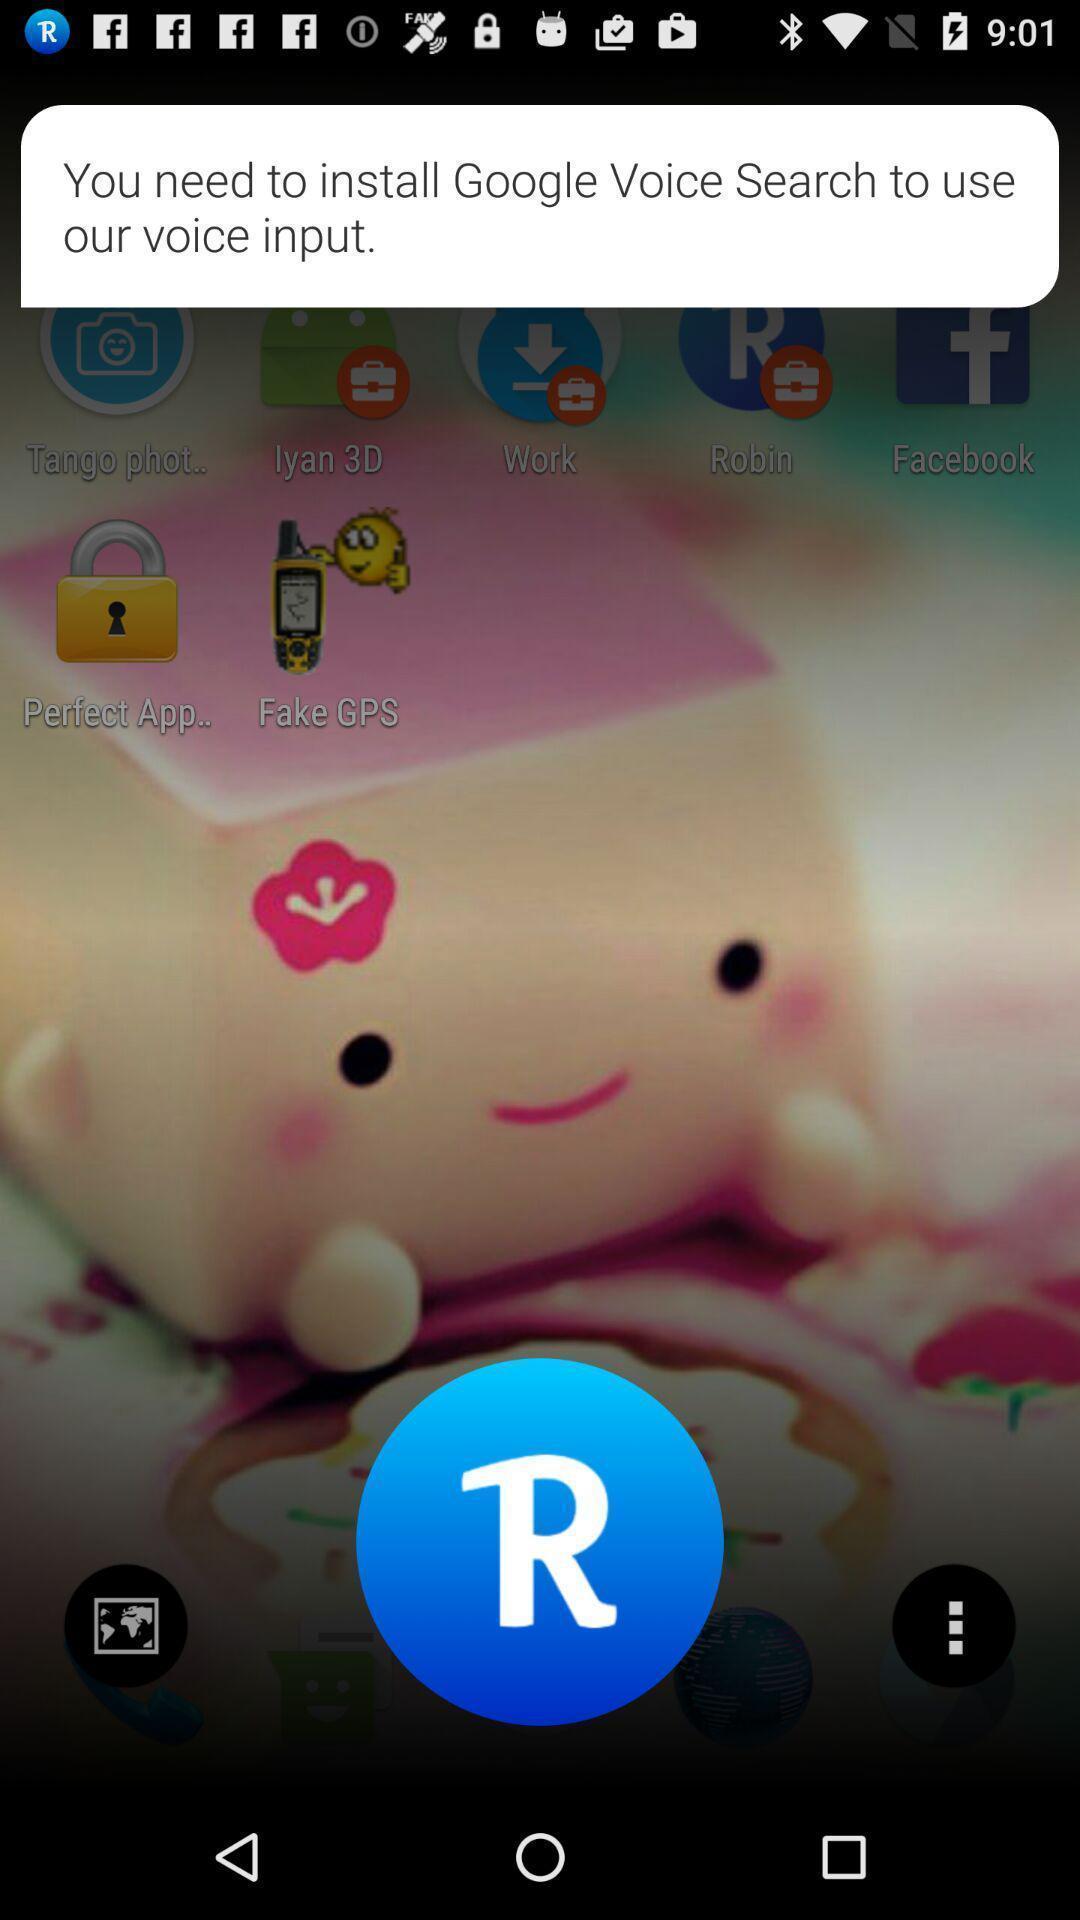Provide a detailed account of this screenshot. Screen displaying the pop-up of installing the app. 